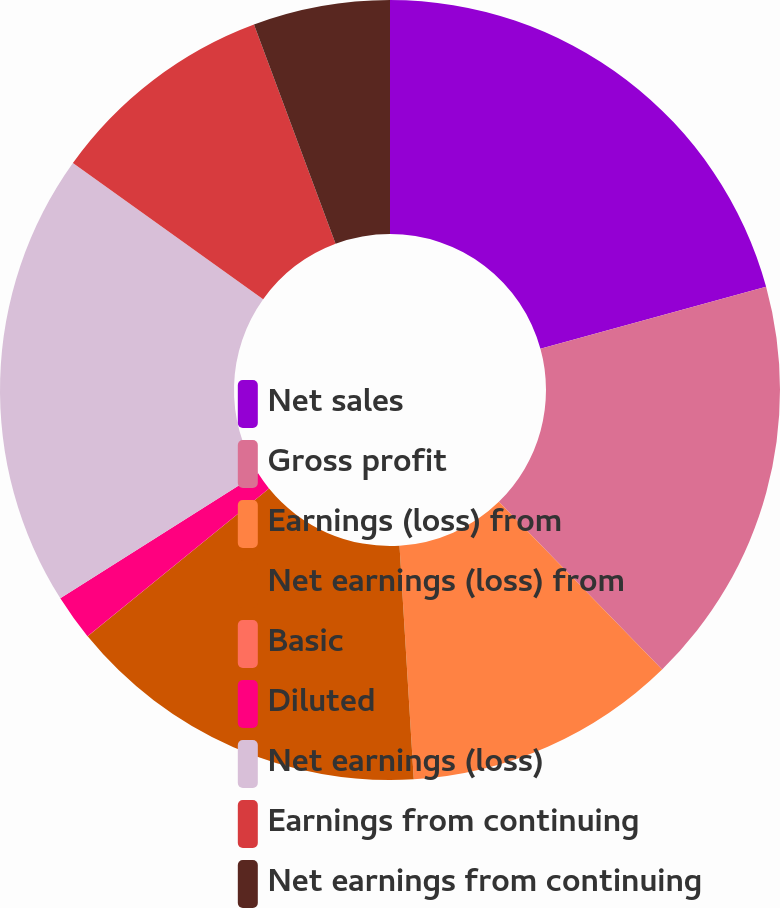<chart> <loc_0><loc_0><loc_500><loc_500><pie_chart><fcel>Net sales<fcel>Gross profit<fcel>Earnings (loss) from<fcel>Net earnings (loss) from<fcel>Basic<fcel>Diluted<fcel>Net earnings (loss)<fcel>Earnings from continuing<fcel>Net earnings from continuing<nl><fcel>20.74%<fcel>16.97%<fcel>11.32%<fcel>15.09%<fcel>0.01%<fcel>1.9%<fcel>18.86%<fcel>9.44%<fcel>5.67%<nl></chart> 